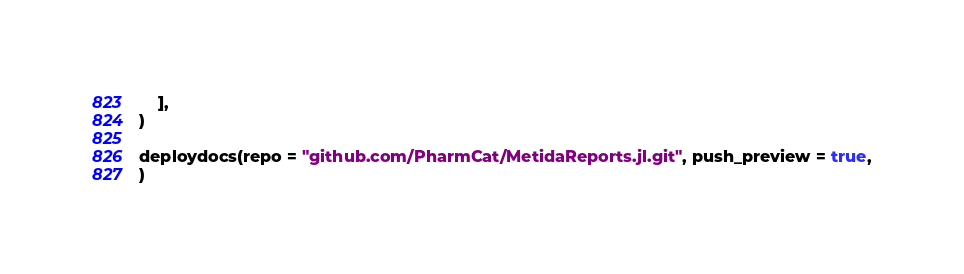<code> <loc_0><loc_0><loc_500><loc_500><_Julia_>    ],
)

deploydocs(repo = "github.com/PharmCat/MetidaReports.jl.git", push_preview = true,
)
</code> 